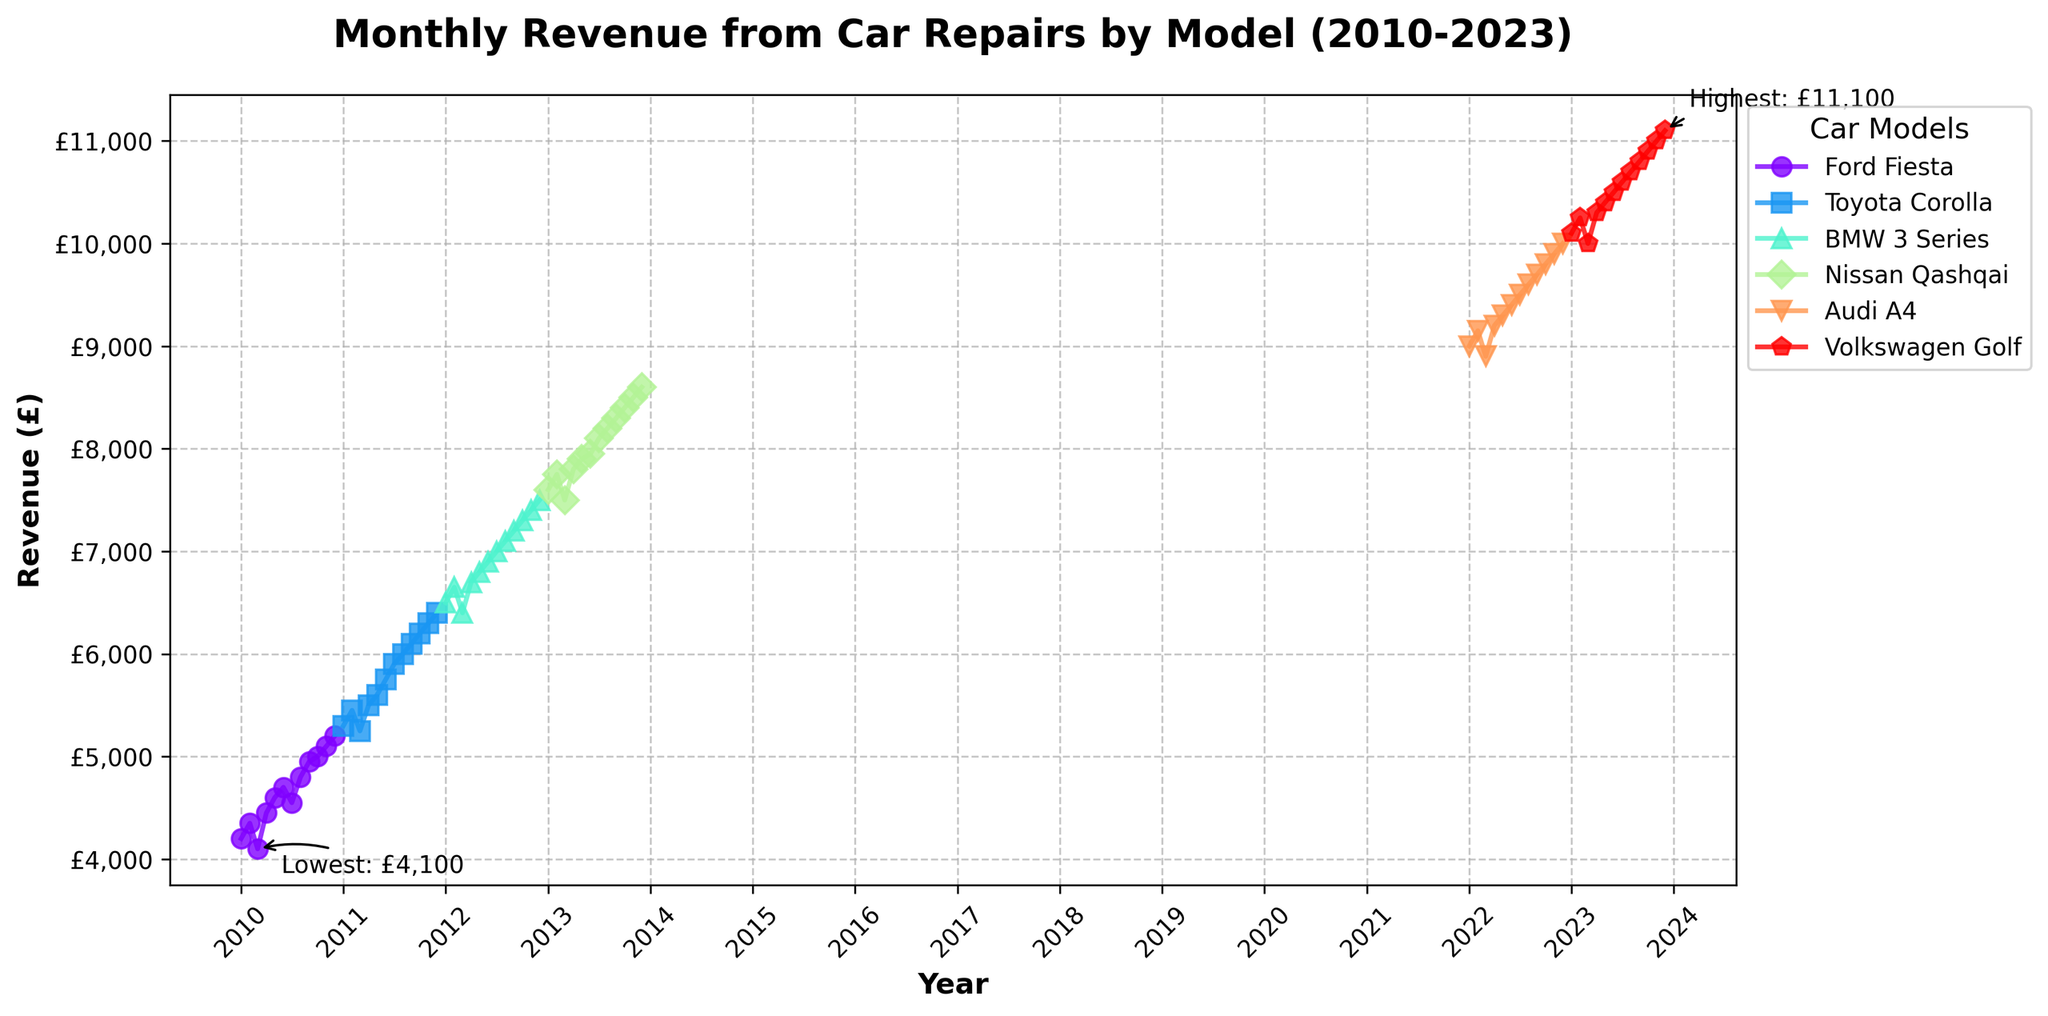What is the title of the plot? The title is usually displayed at the top of the plot. It helps describe the main topic or focus of the figure.
Answer: Monthly Revenue from Car Repairs by Model (2010-2023) Which car model has the highest monthly revenue in the dataset? Look for the highest point on the plot and check which car model is associated with this peak.
Answer: Volkswagen Golf What is the lowest revenue recorded and in which car model and month does it occur? Identify the lowest point on the plot and trace it back to the car model and the specific month.
Answer: £4,100, Ford Fiesta, March 2010 How many car models are displayed in the plot? Count the number of unique lines/points on the plot, each representing a different car model.
Answer: 6 Which car model shows the most consistent increase in revenue over time? Look for the car model whose line continuously trends upwards without many fluctuations or drops.
Answer: Volkswagen Golf Compare the highest revenue of the Ford Fiesta and the Toyota Corolla. Which is higher and by how much? Find the peak values for both Ford Fiesta and Toyota Corolla and then subtract the smaller peak from the larger one to determine the difference.
Answer: Toyota Corolla by £1,200 What year did the BMW 3 Series start appearing on the plot? Follow the line or points associated with the BMW 3 Series and identify the earliest year it is visible.
Answer: 2012 How does the revenue trend for the Nissan Qashqai compare to the Audi A4 between 2013 and 2022? Observe the lines for both models during the specified period and describe whether they increase, decrease, or stay constant.
Answer: Nissan Qashqai shows an increasing trend until 2022, only leveling slightly towards the end, while the Audi A4 starts in 2022 with a rising trend Which two car models have overlapping revenue values and in which months do they overlap, if any? Examine the plot for periods where the lines or points of different models intersect or come very close, and note the car models and months.
Answer: One overlapping instance is unlikely based on the data set, as all values are increasing year-on-year for different car models, but a specific check per the data is required for a precise answer What is the average revenue for the Audi A4 in the year 2022? Add up all the monthly revenues for the Audi A4 in 2022 and divide by the number of months.
Answer: (£9000 + £9150 + £8900 + £9200 + £9300 + £9400 + £9500 + £9600 + £9700 + £9800 + £9900 + £10000) / 12 = £9,550 